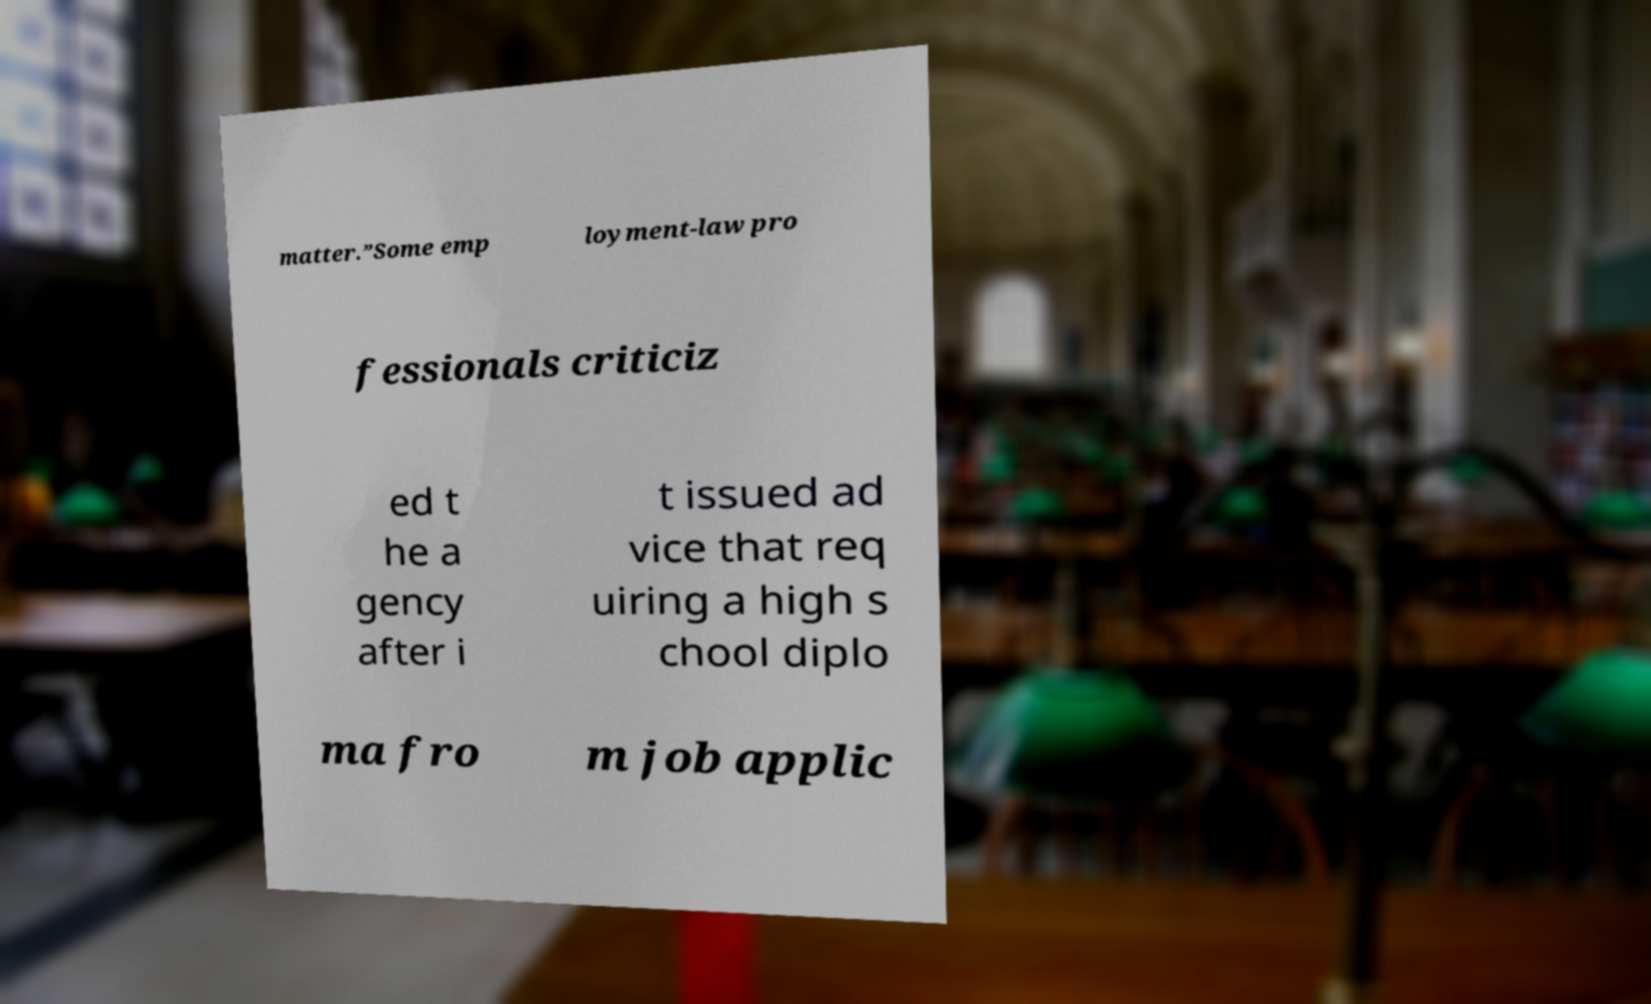What messages or text are displayed in this image? I need them in a readable, typed format. matter.”Some emp loyment-law pro fessionals criticiz ed t he a gency after i t issued ad vice that req uiring a high s chool diplo ma fro m job applic 